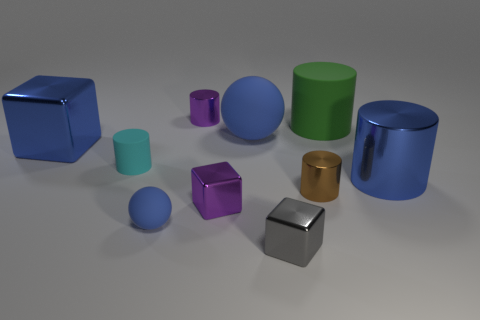Subtract all big blue cylinders. How many cylinders are left? 4 Subtract all spheres. How many objects are left? 8 Subtract 1 blue balls. How many objects are left? 9 Subtract all tiny brown metal cylinders. Subtract all large red rubber spheres. How many objects are left? 9 Add 3 rubber cylinders. How many rubber cylinders are left? 5 Add 5 purple metallic objects. How many purple metallic objects exist? 7 